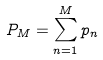Convert formula to latex. <formula><loc_0><loc_0><loc_500><loc_500>P _ { M } = \sum _ { n = 1 } ^ { M } p _ { n }</formula> 